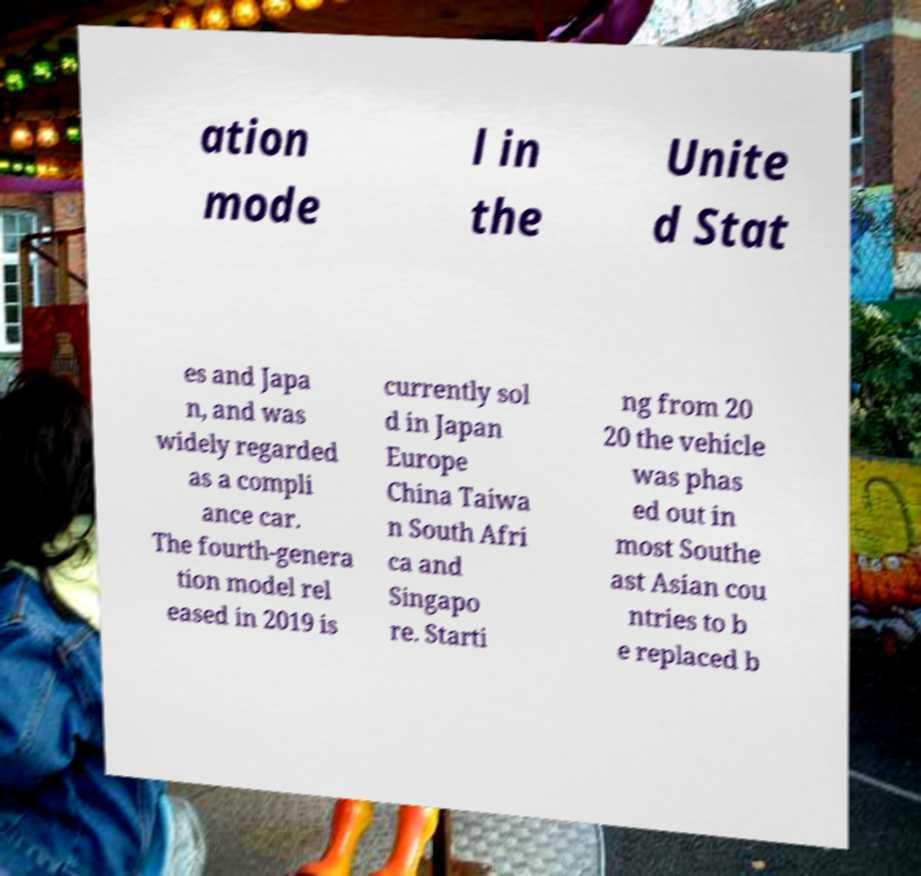Please identify and transcribe the text found in this image. ation mode l in the Unite d Stat es and Japa n, and was widely regarded as a compli ance car. The fourth-genera tion model rel eased in 2019 is currently sol d in Japan Europe China Taiwa n South Afri ca and Singapo re. Starti ng from 20 20 the vehicle was phas ed out in most Southe ast Asian cou ntries to b e replaced b 